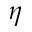<formula> <loc_0><loc_0><loc_500><loc_500>\eta</formula> 